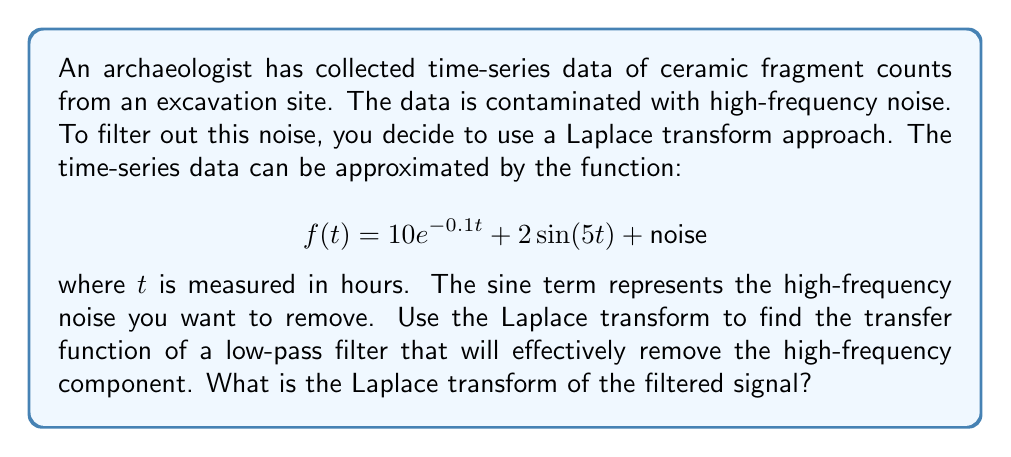Could you help me with this problem? Let's approach this step-by-step:

1) First, we need to take the Laplace transform of $f(t)$. We'll ignore the noise term as it's not part of our mathematical model:

   $$\mathcal{L}\{f(t)\} = \mathcal{L}\{10e^{-0.1t}\} + \mathcal{L}\{2\sin(5t)\}$$

2) Using Laplace transform properties:
   
   $$F(s) = \frac{10}{s+0.1} + \frac{10}{s^2+25}$$

3) To design a low-pass filter, we want to attenuate frequencies higher than the exponential decay. A simple first-order low-pass filter has the transfer function:

   $$H(s) = \frac{1}{1 + \tau s}$$

   where $\tau$ is the time constant.

4) We want to choose $\tau$ such that it passes the exponential term but attenuates the sine term. A good choice would be $\tau = 1/0.1 = 10$. This gives:

   $$H(s) = \frac{1}{1 + 10s}$$

5) The filtered signal in the Laplace domain is the product of the original signal and the filter:

   $$F_{\text{filtered}}(s) = F(s) \cdot H(s) = \left(\frac{10}{s+0.1} + \frac{10}{s^2+25}\right) \cdot \frac{1}{1 + 10s}$$

6) Simplifying:

   $$F_{\text{filtered}}(s) = \frac{10}{(s+0.1)(1 + 10s)} + \frac{10}{(s^2+25)(1 + 10s)}$$

This is the Laplace transform of the filtered signal.
Answer: $$F_{\text{filtered}}(s) = \frac{10}{(s+0.1)(1 + 10s)} + \frac{10}{(s^2+25)(1 + 10s)}$$ 